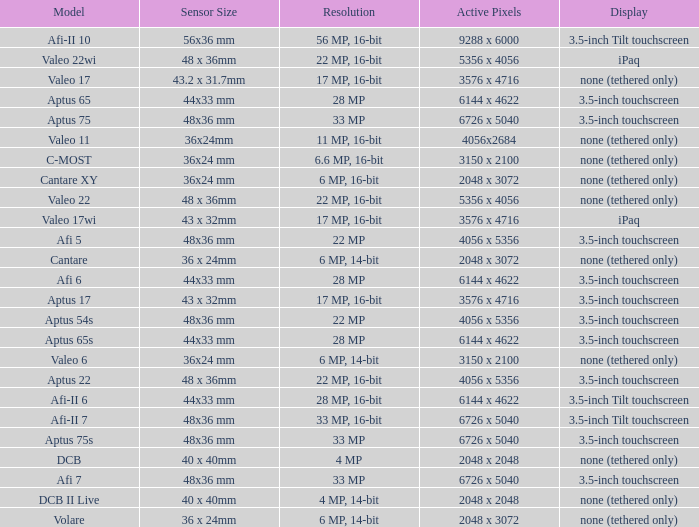What are the active pixels of the c-most model camera? 3150 x 2100. 